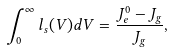Convert formula to latex. <formula><loc_0><loc_0><loc_500><loc_500>\int _ { 0 } ^ { \infty } l _ { s } ( V ) d V = \frac { J _ { e } ^ { 0 } - J _ { g } } { J _ { g } } ,</formula> 